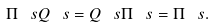Convert formula to latex. <formula><loc_0><loc_0><loc_500><loc_500>\Pi ^ { \ } s Q ^ { \ } s = Q ^ { \ } s \Pi ^ { \ } s = \Pi ^ { \ } s .</formula> 